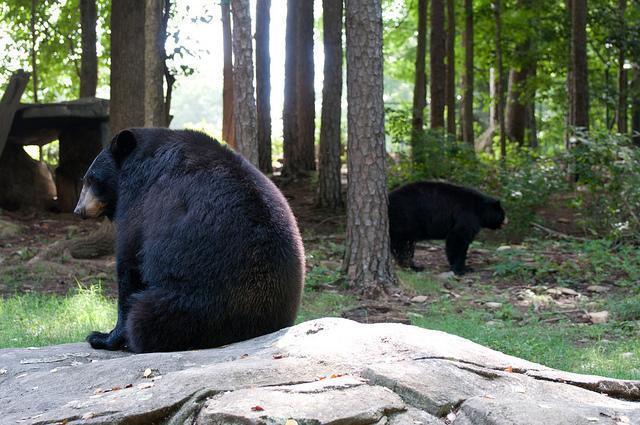How many animals are in this picture?
Give a very brief answer. 2. How many bears are there?
Give a very brief answer. 2. How many ties are there?
Give a very brief answer. 0. 